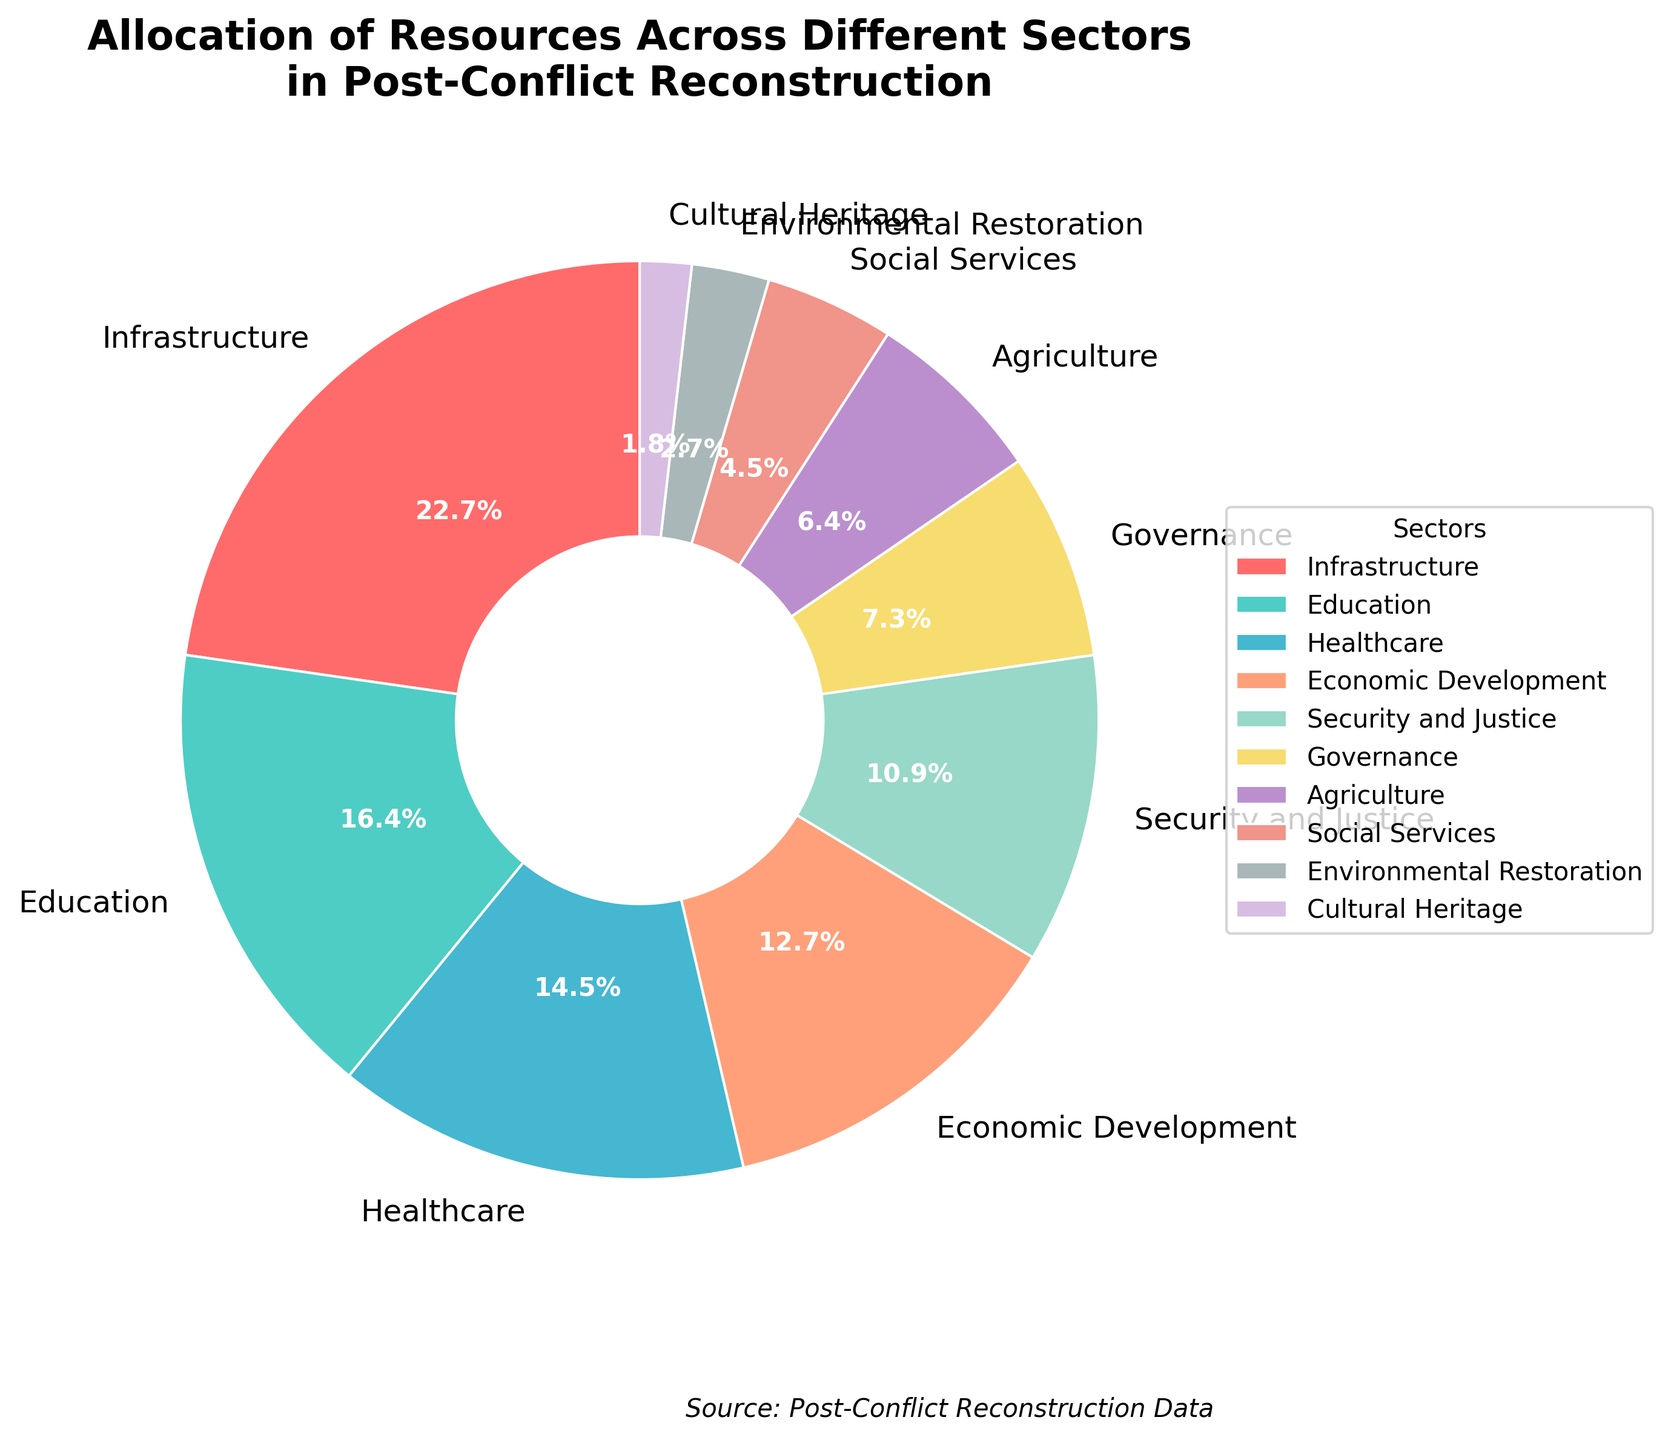Which sector receives the highest allocation of resources? By examining the pie chart, we can see that the sector with the largest percentage value is Infrastructure, which has 25%. Therefore, Infrastructure receives the highest allocation of resources.
Answer: Infrastructure What is the combined percentage allocation for Economic Development and Agriculture? To find the combined allocation, sum the percentages of Economic Development (14%) and Agriculture (7%). Therefore, the combined allocation is 14% + 7% = 21%.
Answer: 21% Is the percentage for Healthcare greater than that for Governance? By looking at the chart, the percentage allocation for Healthcare is 16% and for Governance, it is 8%. Since 16% is greater than 8%, Healthcare's allocation is greater than Governance's.
Answer: Yes Which sector receives the lowest allocation of resources and what is its percentage? From the pie chart, the sector with the smallest segment is Cultural Heritage. The percentage allocation for Cultural Heritage is given as 2%. Therefore, Cultural Heritage receives the lowest allocation of resources.
Answer: Cultural Heritage, 2% What is the difference in resource allocation between Security and Justice and Social Services? The allocation for Security and Justice is 12%, while for Social Services, it is 5%. To find the difference, subtract the smaller percentage from the larger percentage: 12% - 5% = 7%.
Answer: 7% Which sector is represented by the green segment in the pie chart? From the visual, the green segment corresponds to the second-largest wedge, which represents Education. Therefore, the green segment is for Education.
Answer: Education If we combine the resource allocations for Environmental Restoration and Agriculture, does it exceed the allocation for Economic Development? Environmental Restoration has 3%, and Agriculture has 7%. Together, their combined allocation is 3% + 7% = 10%. Since Economic Development has 14%, the combined allocation of Environmental Restoration and Agriculture does not exceed Economic Development's allocation.
Answer: No 